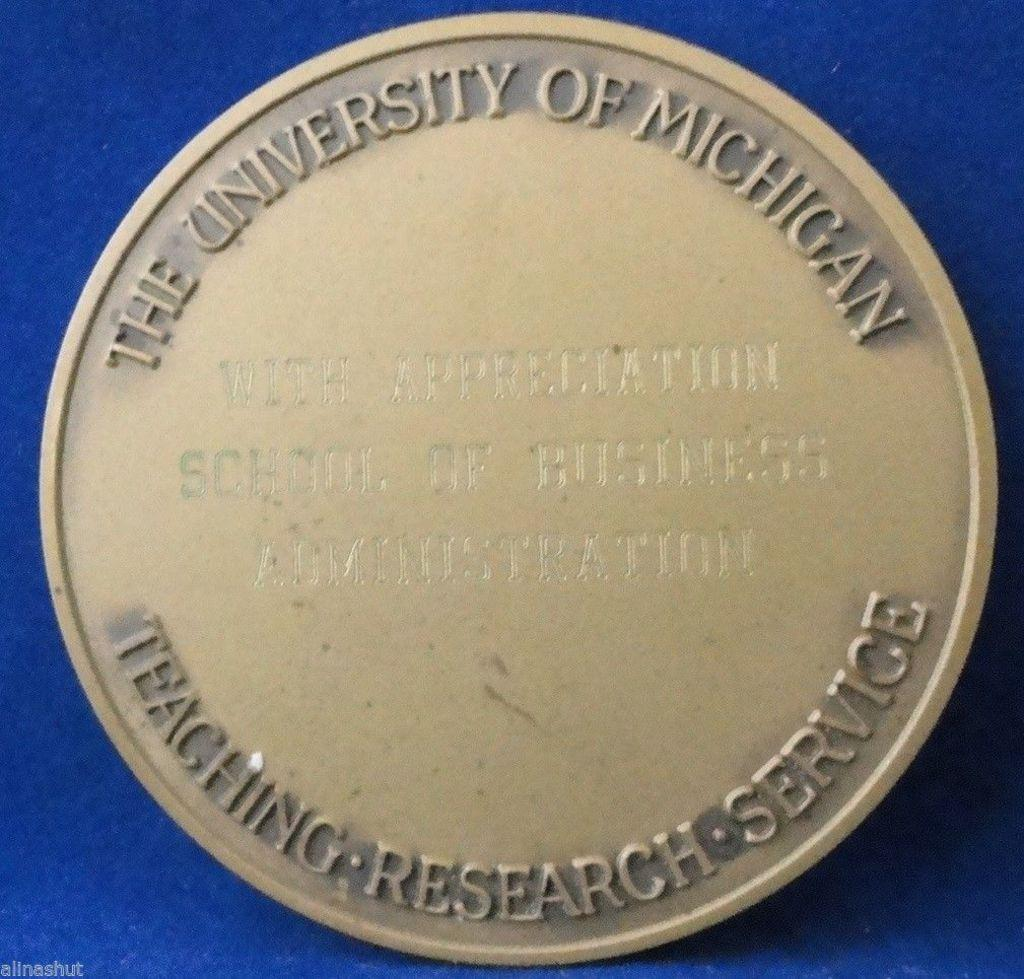<image>
Summarize the visual content of the image. A round gold plaque from the University of Michigan for Teaching, Researh and Service 